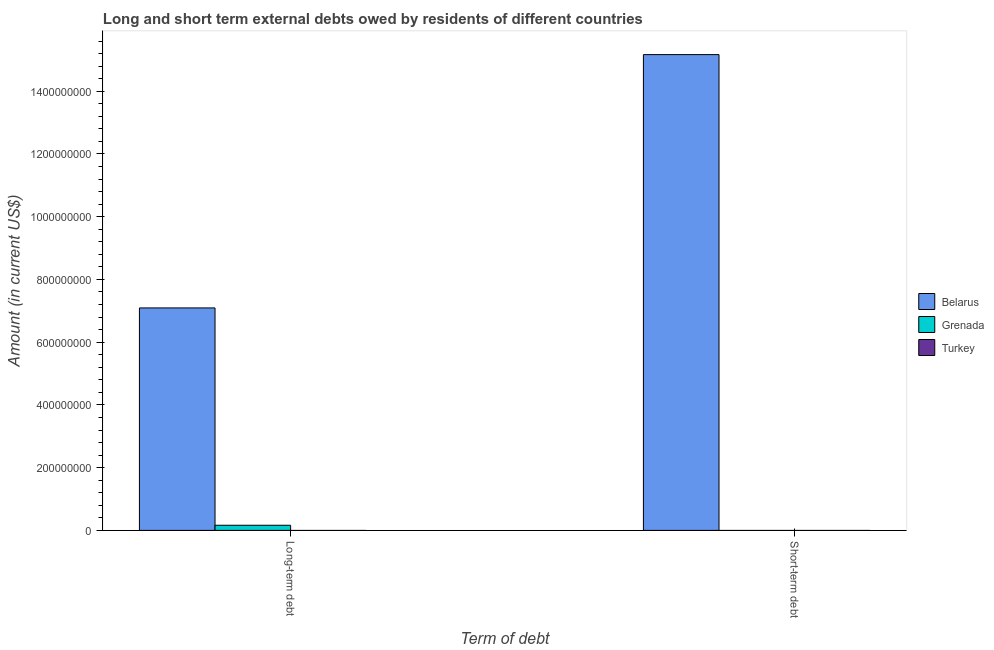Are the number of bars on each tick of the X-axis equal?
Offer a terse response. No. How many bars are there on the 1st tick from the left?
Make the answer very short. 2. How many bars are there on the 2nd tick from the right?
Offer a terse response. 2. What is the label of the 2nd group of bars from the left?
Give a very brief answer. Short-term debt. What is the long-term debts owed by residents in Grenada?
Offer a terse response. 1.63e+07. Across all countries, what is the maximum long-term debts owed by residents?
Your answer should be very brief. 7.09e+08. Across all countries, what is the minimum short-term debts owed by residents?
Ensure brevity in your answer.  0. In which country was the long-term debts owed by residents maximum?
Your answer should be very brief. Belarus. What is the total short-term debts owed by residents in the graph?
Your answer should be compact. 1.52e+09. What is the difference between the long-term debts owed by residents in Grenada and that in Belarus?
Your answer should be compact. -6.93e+08. What is the difference between the short-term debts owed by residents in Belarus and the long-term debts owed by residents in Turkey?
Your answer should be very brief. 1.52e+09. What is the average long-term debts owed by residents per country?
Offer a terse response. 2.42e+08. What is the difference between the long-term debts owed by residents and short-term debts owed by residents in Belarus?
Keep it short and to the point. -8.08e+08. In how many countries, is the short-term debts owed by residents greater than 1120000000 US$?
Ensure brevity in your answer.  1. In how many countries, is the long-term debts owed by residents greater than the average long-term debts owed by residents taken over all countries?
Ensure brevity in your answer.  1. Are all the bars in the graph horizontal?
Make the answer very short. No. How many countries are there in the graph?
Offer a very short reply. 3. Are the values on the major ticks of Y-axis written in scientific E-notation?
Provide a succinct answer. No. Does the graph contain any zero values?
Keep it short and to the point. Yes. Where does the legend appear in the graph?
Give a very brief answer. Center right. What is the title of the graph?
Give a very brief answer. Long and short term external debts owed by residents of different countries. Does "Timor-Leste" appear as one of the legend labels in the graph?
Keep it short and to the point. No. What is the label or title of the X-axis?
Keep it short and to the point. Term of debt. What is the label or title of the Y-axis?
Your answer should be compact. Amount (in current US$). What is the Amount (in current US$) in Belarus in Long-term debt?
Keep it short and to the point. 7.09e+08. What is the Amount (in current US$) in Grenada in Long-term debt?
Offer a very short reply. 1.63e+07. What is the Amount (in current US$) in Belarus in Short-term debt?
Provide a short and direct response. 1.52e+09. What is the Amount (in current US$) of Grenada in Short-term debt?
Make the answer very short. 0. Across all Term of debt, what is the maximum Amount (in current US$) in Belarus?
Offer a terse response. 1.52e+09. Across all Term of debt, what is the maximum Amount (in current US$) in Grenada?
Offer a terse response. 1.63e+07. Across all Term of debt, what is the minimum Amount (in current US$) in Belarus?
Ensure brevity in your answer.  7.09e+08. What is the total Amount (in current US$) of Belarus in the graph?
Offer a terse response. 2.23e+09. What is the total Amount (in current US$) of Grenada in the graph?
Offer a very short reply. 1.63e+07. What is the total Amount (in current US$) of Turkey in the graph?
Provide a short and direct response. 0. What is the difference between the Amount (in current US$) of Belarus in Long-term debt and that in Short-term debt?
Your response must be concise. -8.08e+08. What is the average Amount (in current US$) in Belarus per Term of debt?
Give a very brief answer. 1.11e+09. What is the average Amount (in current US$) in Grenada per Term of debt?
Your response must be concise. 8.16e+06. What is the difference between the Amount (in current US$) in Belarus and Amount (in current US$) in Grenada in Long-term debt?
Keep it short and to the point. 6.93e+08. What is the ratio of the Amount (in current US$) in Belarus in Long-term debt to that in Short-term debt?
Offer a terse response. 0.47. What is the difference between the highest and the second highest Amount (in current US$) of Belarus?
Ensure brevity in your answer.  8.08e+08. What is the difference between the highest and the lowest Amount (in current US$) in Belarus?
Your response must be concise. 8.08e+08. What is the difference between the highest and the lowest Amount (in current US$) of Grenada?
Offer a terse response. 1.63e+07. 